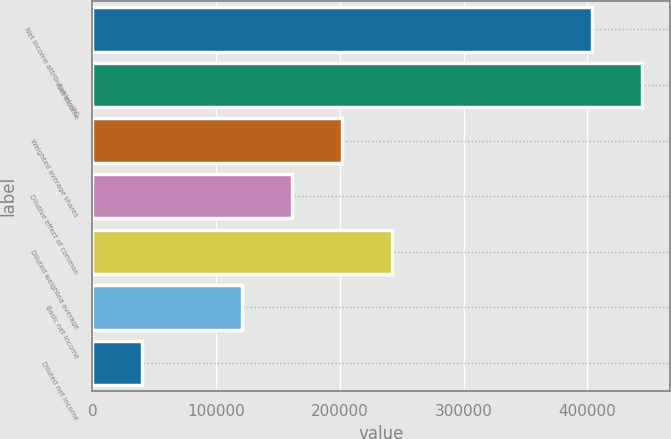Convert chart to OTSL. <chart><loc_0><loc_0><loc_500><loc_500><bar_chart><fcel>Net income attributabletoIPG<fcel>Net income<fcel>Weighted average shares<fcel>Dilutive effect of common<fcel>Diluted weighted average<fcel>Basic net income<fcel>Diluted net income<nl><fcel>404027<fcel>444429<fcel>202017<fcel>161615<fcel>242419<fcel>121213<fcel>40409.3<nl></chart> 